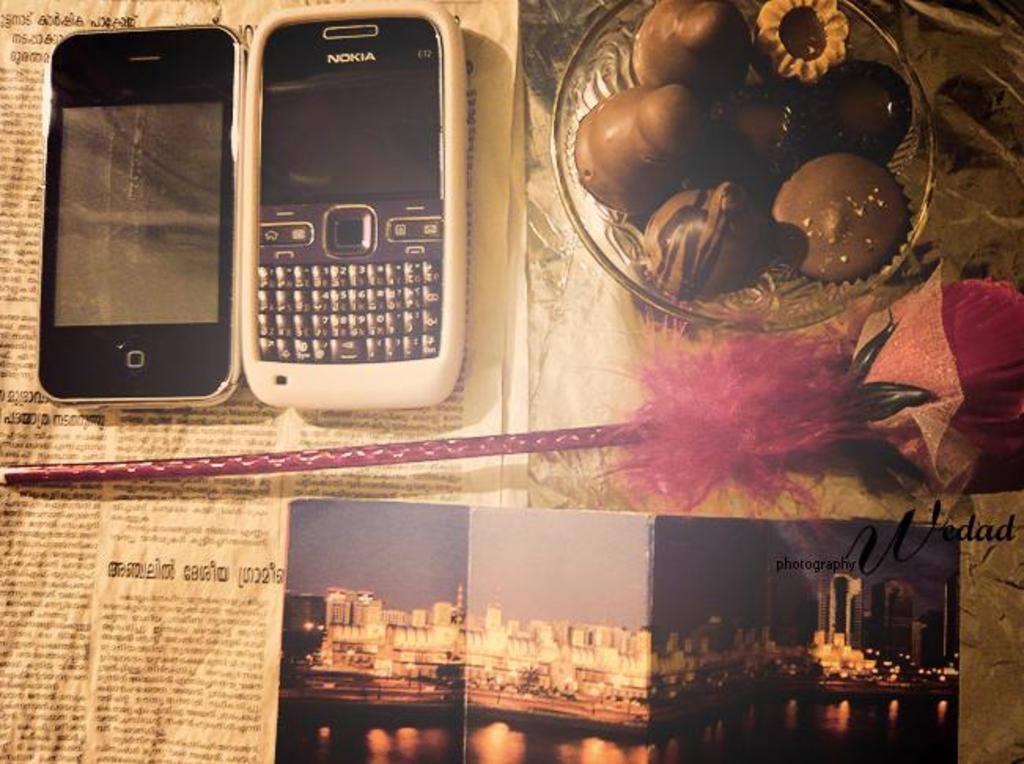What brand is the white phone?
Offer a terse response. Nokia. 